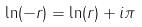<formula> <loc_0><loc_0><loc_500><loc_500>\ln ( - r ) = \ln ( r ) + i \pi</formula> 